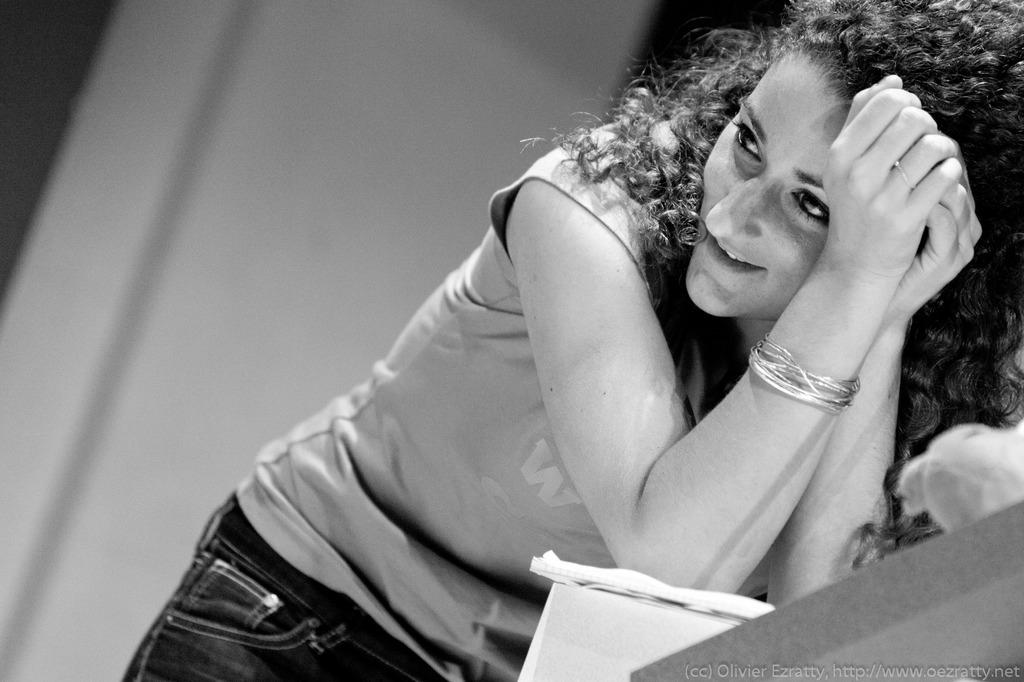What is the color scheme of the image? The image is black and white. What is the woman in the image doing? The woman is standing at the table in the image. What can be seen in the background of the image? There is a wall in the background of the image. What type of jam is the woman spreading on the wall in the image? There is no jam or any indication of spreading in the image; it only shows a woman standing at a table with a wall in the background. 